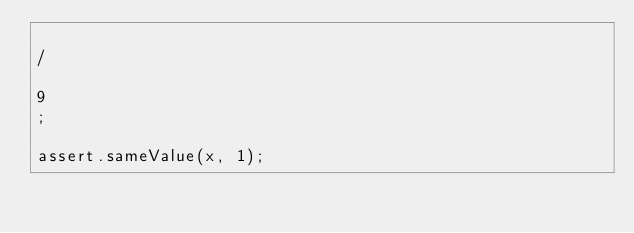Convert code to text. <code><loc_0><loc_0><loc_500><loc_500><_JavaScript_>
/

9
;

assert.sameValue(x, 1);
</code> 